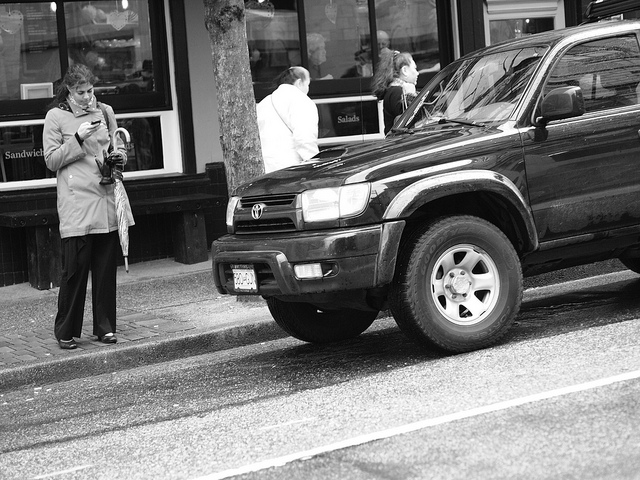<image>Is the woman looking at the cell phone aware of the car in front of her? No, the woman looking at the cell phone may not be aware of the car in front of her. What is the license plate number of the parked car? It is impossible to determine the license plate number as it is not clearly visible in the image. Is the woman looking at the cell phone aware of the car in front of her? I don't know if the woman looking at the cell phone is aware of the car in front of her. What is the license plate number of the parked car? I don't know the license plate number of the parked car. It is either unknown or cannot be seen clearly. 